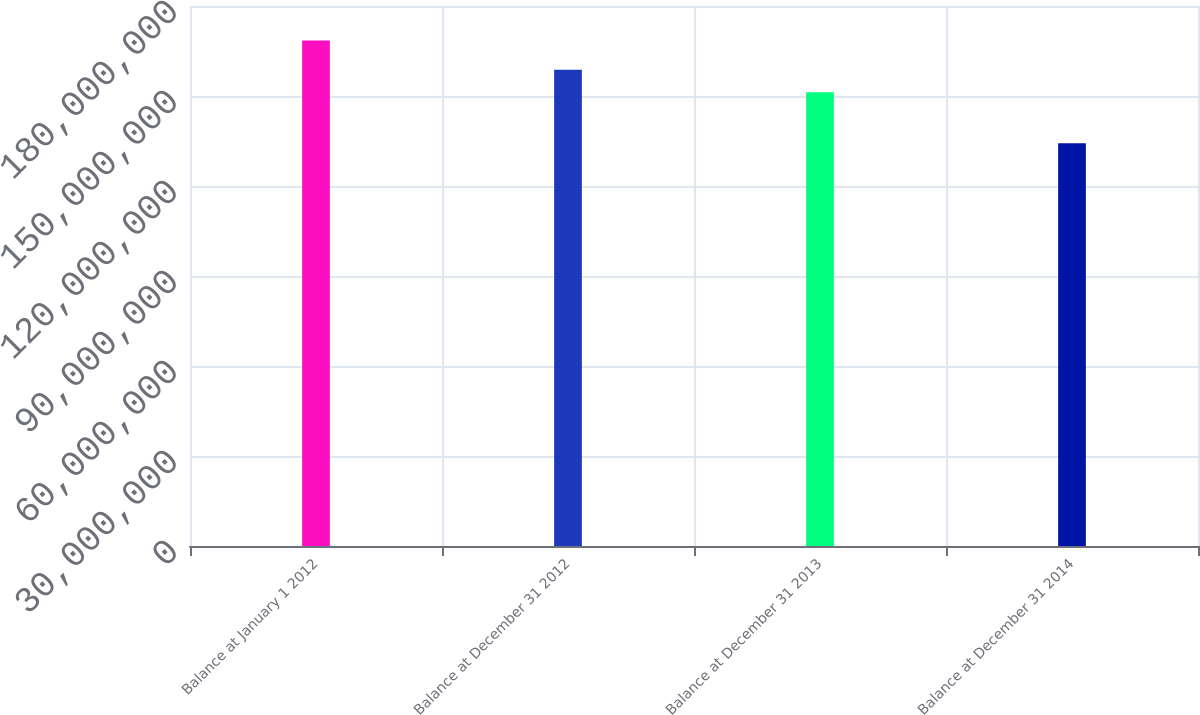Convert chart. <chart><loc_0><loc_0><loc_500><loc_500><bar_chart><fcel>Balance at January 1 2012<fcel>Balance at December 31 2012<fcel>Balance at December 31 2013<fcel>Balance at December 31 2014<nl><fcel>1.68468e+08<fcel>1.58718e+08<fcel>1.51218e+08<fcel>1.34218e+08<nl></chart> 